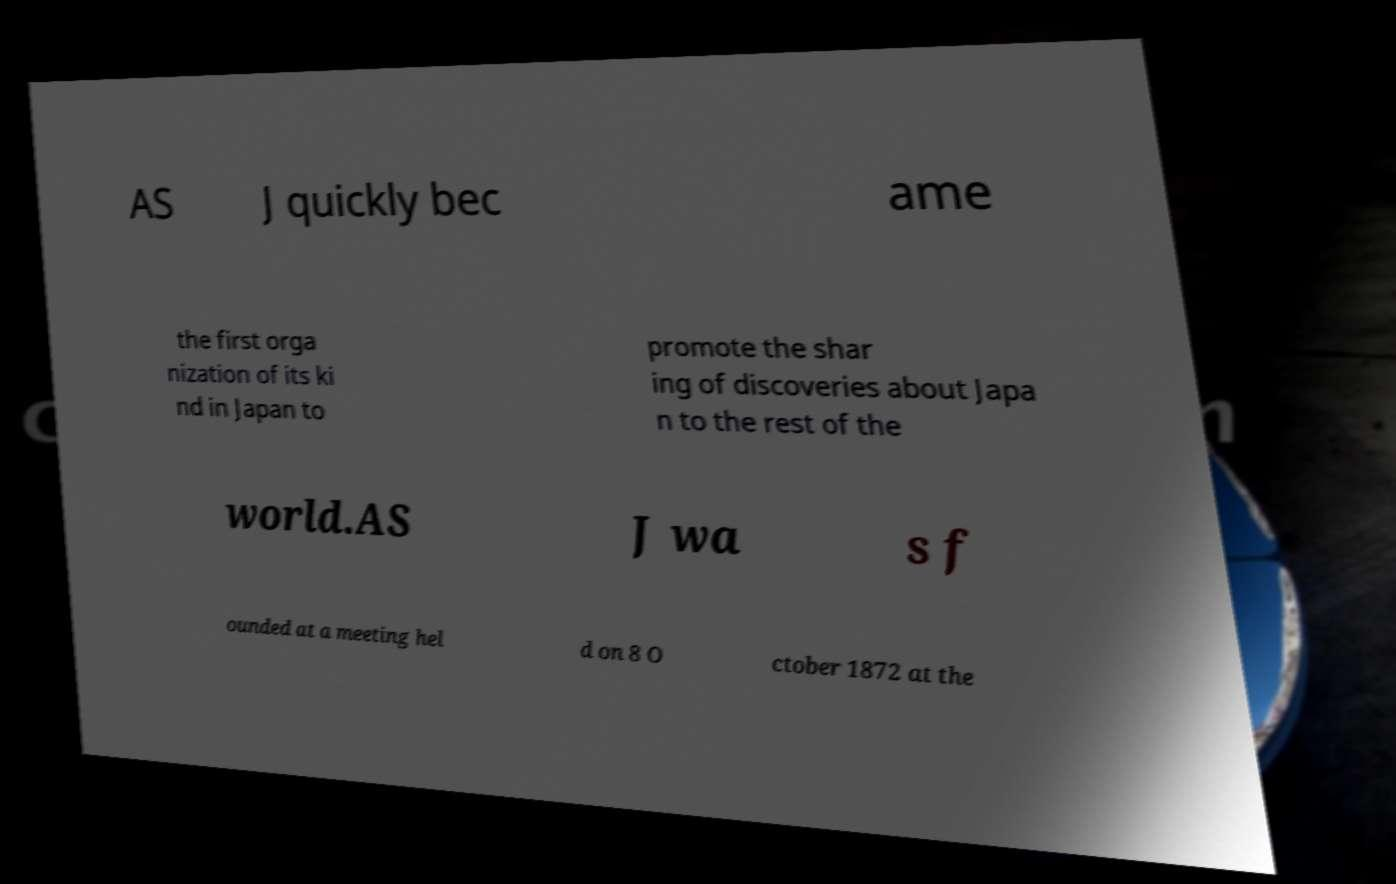There's text embedded in this image that I need extracted. Can you transcribe it verbatim? AS J quickly bec ame the first orga nization of its ki nd in Japan to promote the shar ing of discoveries about Japa n to the rest of the world.AS J wa s f ounded at a meeting hel d on 8 O ctober 1872 at the 